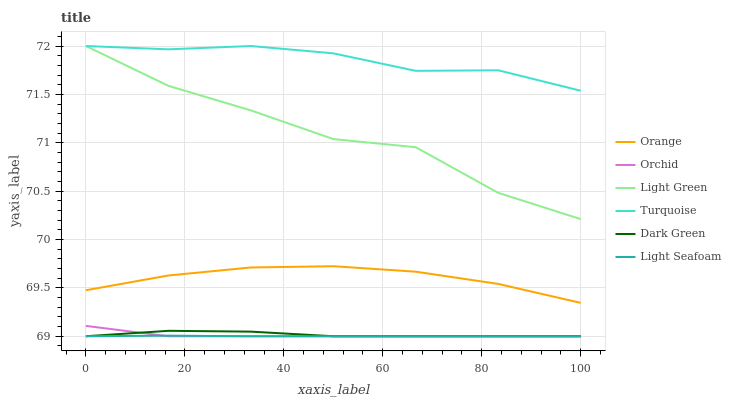Does Light Green have the minimum area under the curve?
Answer yes or no. No. Does Light Green have the maximum area under the curve?
Answer yes or no. No. Is Turquoise the smoothest?
Answer yes or no. No. Is Turquoise the roughest?
Answer yes or no. No. Does Light Green have the lowest value?
Answer yes or no. No. Does Orange have the highest value?
Answer yes or no. No. Is Orange less than Light Green?
Answer yes or no. Yes. Is Light Green greater than Dark Green?
Answer yes or no. Yes. Does Orange intersect Light Green?
Answer yes or no. No. 